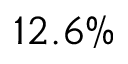<formula> <loc_0><loc_0><loc_500><loc_500>1 2 . 6 \%</formula> 